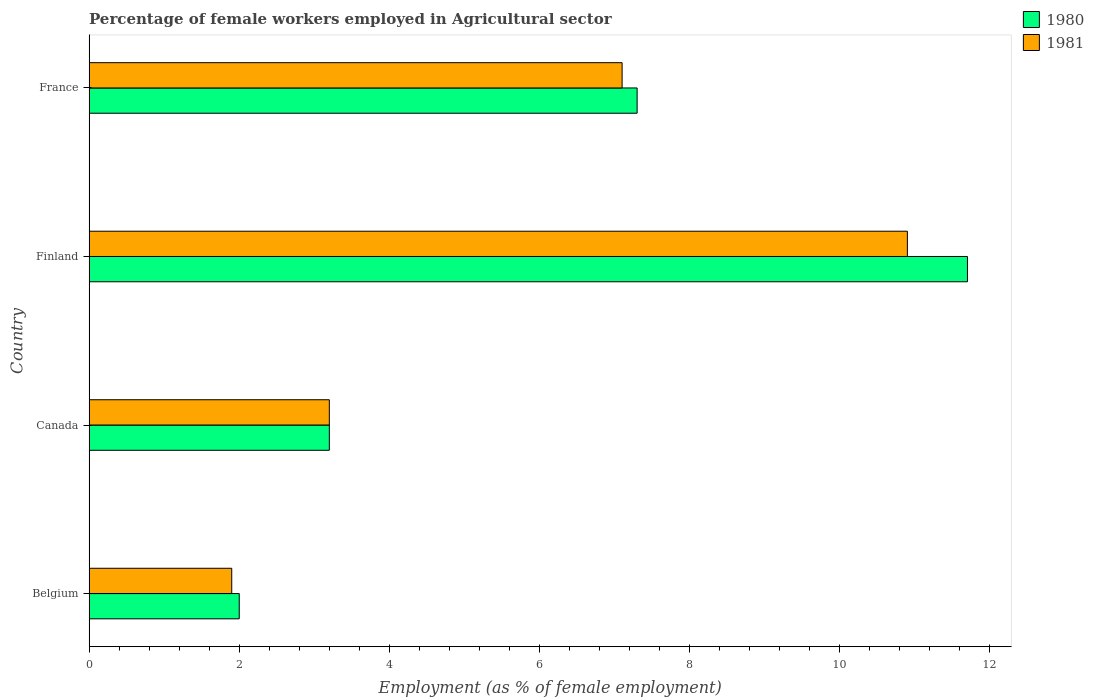Are the number of bars on each tick of the Y-axis equal?
Your response must be concise. Yes. What is the label of the 1st group of bars from the top?
Your answer should be very brief. France. In how many cases, is the number of bars for a given country not equal to the number of legend labels?
Make the answer very short. 0. What is the percentage of females employed in Agricultural sector in 1980 in Belgium?
Provide a succinct answer. 2. Across all countries, what is the maximum percentage of females employed in Agricultural sector in 1980?
Your response must be concise. 11.7. Across all countries, what is the minimum percentage of females employed in Agricultural sector in 1981?
Offer a very short reply. 1.9. In which country was the percentage of females employed in Agricultural sector in 1981 maximum?
Provide a succinct answer. Finland. In which country was the percentage of females employed in Agricultural sector in 1980 minimum?
Make the answer very short. Belgium. What is the total percentage of females employed in Agricultural sector in 1980 in the graph?
Your response must be concise. 24.2. What is the difference between the percentage of females employed in Agricultural sector in 1981 in Belgium and that in Canada?
Ensure brevity in your answer.  -1.3. What is the difference between the percentage of females employed in Agricultural sector in 1980 in Finland and the percentage of females employed in Agricultural sector in 1981 in France?
Your response must be concise. 4.6. What is the average percentage of females employed in Agricultural sector in 1981 per country?
Ensure brevity in your answer.  5.77. What is the difference between the percentage of females employed in Agricultural sector in 1980 and percentage of females employed in Agricultural sector in 1981 in Finland?
Keep it short and to the point. 0.8. In how many countries, is the percentage of females employed in Agricultural sector in 1981 greater than 8.4 %?
Make the answer very short. 1. What is the ratio of the percentage of females employed in Agricultural sector in 1981 in Finland to that in France?
Give a very brief answer. 1.54. Is the difference between the percentage of females employed in Agricultural sector in 1980 in Belgium and Canada greater than the difference between the percentage of females employed in Agricultural sector in 1981 in Belgium and Canada?
Your response must be concise. Yes. What is the difference between the highest and the second highest percentage of females employed in Agricultural sector in 1981?
Your answer should be very brief. 3.8. What is the difference between the highest and the lowest percentage of females employed in Agricultural sector in 1980?
Offer a very short reply. 9.7. Is the sum of the percentage of females employed in Agricultural sector in 1981 in Belgium and Finland greater than the maximum percentage of females employed in Agricultural sector in 1980 across all countries?
Your response must be concise. Yes. What does the 1st bar from the top in Canada represents?
Your answer should be compact. 1981. What does the 2nd bar from the bottom in Canada represents?
Your answer should be very brief. 1981. How many countries are there in the graph?
Provide a succinct answer. 4. What is the difference between two consecutive major ticks on the X-axis?
Keep it short and to the point. 2. Are the values on the major ticks of X-axis written in scientific E-notation?
Provide a short and direct response. No. Does the graph contain any zero values?
Your answer should be very brief. No. Where does the legend appear in the graph?
Your answer should be compact. Top right. What is the title of the graph?
Offer a terse response. Percentage of female workers employed in Agricultural sector. What is the label or title of the X-axis?
Make the answer very short. Employment (as % of female employment). What is the label or title of the Y-axis?
Your answer should be very brief. Country. What is the Employment (as % of female employment) in 1980 in Belgium?
Your answer should be very brief. 2. What is the Employment (as % of female employment) in 1981 in Belgium?
Your answer should be compact. 1.9. What is the Employment (as % of female employment) in 1980 in Canada?
Your response must be concise. 3.2. What is the Employment (as % of female employment) in 1981 in Canada?
Provide a short and direct response. 3.2. What is the Employment (as % of female employment) in 1980 in Finland?
Offer a terse response. 11.7. What is the Employment (as % of female employment) in 1981 in Finland?
Your answer should be very brief. 10.9. What is the Employment (as % of female employment) of 1980 in France?
Your answer should be compact. 7.3. What is the Employment (as % of female employment) in 1981 in France?
Provide a short and direct response. 7.1. Across all countries, what is the maximum Employment (as % of female employment) of 1980?
Make the answer very short. 11.7. Across all countries, what is the maximum Employment (as % of female employment) of 1981?
Give a very brief answer. 10.9. Across all countries, what is the minimum Employment (as % of female employment) of 1981?
Keep it short and to the point. 1.9. What is the total Employment (as % of female employment) of 1980 in the graph?
Offer a terse response. 24.2. What is the total Employment (as % of female employment) in 1981 in the graph?
Make the answer very short. 23.1. What is the difference between the Employment (as % of female employment) of 1980 in Canada and that in Finland?
Make the answer very short. -8.5. What is the difference between the Employment (as % of female employment) in 1981 in Canada and that in France?
Your answer should be compact. -3.9. What is the difference between the Employment (as % of female employment) in 1980 in Finland and that in France?
Give a very brief answer. 4.4. What is the difference between the Employment (as % of female employment) of 1981 in Finland and that in France?
Make the answer very short. 3.8. What is the difference between the Employment (as % of female employment) of 1980 in Belgium and the Employment (as % of female employment) of 1981 in France?
Your answer should be very brief. -5.1. What is the average Employment (as % of female employment) of 1980 per country?
Offer a very short reply. 6.05. What is the average Employment (as % of female employment) of 1981 per country?
Ensure brevity in your answer.  5.78. What is the difference between the Employment (as % of female employment) of 1980 and Employment (as % of female employment) of 1981 in Canada?
Your answer should be compact. 0. What is the ratio of the Employment (as % of female employment) of 1980 in Belgium to that in Canada?
Keep it short and to the point. 0.62. What is the ratio of the Employment (as % of female employment) in 1981 in Belgium to that in Canada?
Ensure brevity in your answer.  0.59. What is the ratio of the Employment (as % of female employment) in 1980 in Belgium to that in Finland?
Your answer should be compact. 0.17. What is the ratio of the Employment (as % of female employment) in 1981 in Belgium to that in Finland?
Provide a succinct answer. 0.17. What is the ratio of the Employment (as % of female employment) in 1980 in Belgium to that in France?
Your response must be concise. 0.27. What is the ratio of the Employment (as % of female employment) of 1981 in Belgium to that in France?
Your answer should be very brief. 0.27. What is the ratio of the Employment (as % of female employment) in 1980 in Canada to that in Finland?
Provide a short and direct response. 0.27. What is the ratio of the Employment (as % of female employment) in 1981 in Canada to that in Finland?
Provide a short and direct response. 0.29. What is the ratio of the Employment (as % of female employment) of 1980 in Canada to that in France?
Provide a succinct answer. 0.44. What is the ratio of the Employment (as % of female employment) in 1981 in Canada to that in France?
Your response must be concise. 0.45. What is the ratio of the Employment (as % of female employment) of 1980 in Finland to that in France?
Your answer should be compact. 1.6. What is the ratio of the Employment (as % of female employment) in 1981 in Finland to that in France?
Make the answer very short. 1.54. What is the difference between the highest and the second highest Employment (as % of female employment) in 1980?
Your answer should be compact. 4.4. What is the difference between the highest and the lowest Employment (as % of female employment) of 1980?
Give a very brief answer. 9.7. What is the difference between the highest and the lowest Employment (as % of female employment) of 1981?
Offer a terse response. 9. 